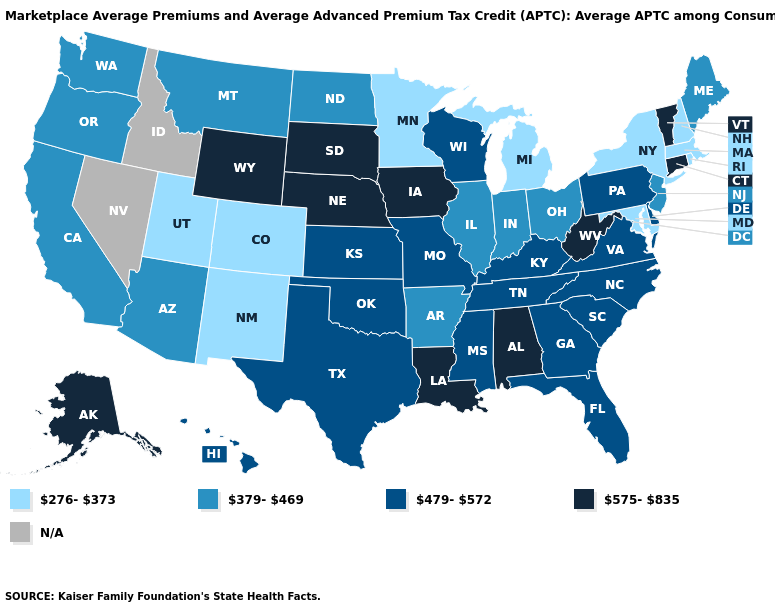Name the states that have a value in the range 276-373?
Give a very brief answer. Colorado, Maryland, Massachusetts, Michigan, Minnesota, New Hampshire, New Mexico, New York, Rhode Island, Utah. Name the states that have a value in the range N/A?
Be succinct. Idaho, Nevada. Does the first symbol in the legend represent the smallest category?
Concise answer only. Yes. What is the highest value in the MidWest ?
Keep it brief. 575-835. Does Vermont have the highest value in the USA?
Short answer required. Yes. Name the states that have a value in the range 575-835?
Concise answer only. Alabama, Alaska, Connecticut, Iowa, Louisiana, Nebraska, South Dakota, Vermont, West Virginia, Wyoming. Is the legend a continuous bar?
Quick response, please. No. What is the value of Montana?
Write a very short answer. 379-469. Does the map have missing data?
Short answer required. Yes. What is the value of Virginia?
Keep it brief. 479-572. What is the value of Vermont?
Concise answer only. 575-835. Among the states that border Nebraska , does Iowa have the highest value?
Keep it brief. Yes. Which states have the lowest value in the USA?
Give a very brief answer. Colorado, Maryland, Massachusetts, Michigan, Minnesota, New Hampshire, New Mexico, New York, Rhode Island, Utah. What is the value of Kansas?
Keep it brief. 479-572. 